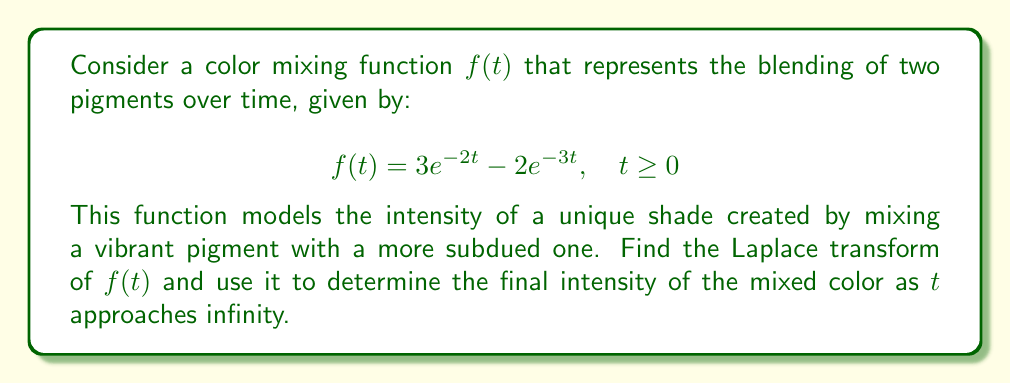What is the answer to this math problem? To solve this problem, we'll follow these steps:

1) First, let's recall the Laplace transform of an exponential function:
   $$\mathcal{L}\{e^{at}\} = \frac{1}{s-a}$$

2) Now, we can apply the Laplace transform to our function $f(t)$:
   $$\mathcal{L}\{f(t)\} = \mathcal{L}\{3e^{-2t} - 2e^{-3t}\}$$

3) Using the linearity property of the Laplace transform:
   $$\mathcal{L}\{f(t)\} = 3\mathcal{L}\{e^{-2t}\} - 2\mathcal{L}\{e^{-3t}\}$$

4) Applying the formula from step 1:
   $$\mathcal{L}\{f(t)\} = 3\cdot\frac{1}{s-(-2)} - 2\cdot\frac{1}{s-(-3)}$$

5) Simplifying:
   $$\mathcal{L}\{f(t)\} = \frac{3}{s+2} - \frac{2}{s+3}$$

6) This is the Laplace transform of our color mixing function.

7) To find the final intensity as $t$ approaches infinity, we can use the Final Value Theorem:
   $$\lim_{t\to\infty} f(t) = \lim_{s\to 0} s\cdot F(s)$$
   where $F(s)$ is the Laplace transform of $f(t)$.

8) Applying this theorem:
   $$\lim_{t\to\infty} f(t) = \lim_{s\to 0} s\cdot(\frac{3}{s+2} - \frac{2}{s+3})$$

9) Simplifying:
   $$\lim_{t\to\infty} f(t) = \lim_{s\to 0} (\frac{3s}{s+2} - \frac{2s}{s+3})$$

10) As $s$ approaches 0, this limit evaluates to:
    $$\lim_{t\to\infty} f(t) = \frac{3\cdot0}{0+2} - \frac{2\cdot0}{0+3} = 0 - 0 = 0$$

Therefore, the final intensity of the mixed color as $t$ approaches infinity is 0.
Answer: The Laplace transform of $f(t)$ is $F(s) = \frac{3}{s+2} - \frac{2}{s+3}$, and the final intensity of the mixed color as $t$ approaches infinity is 0. 